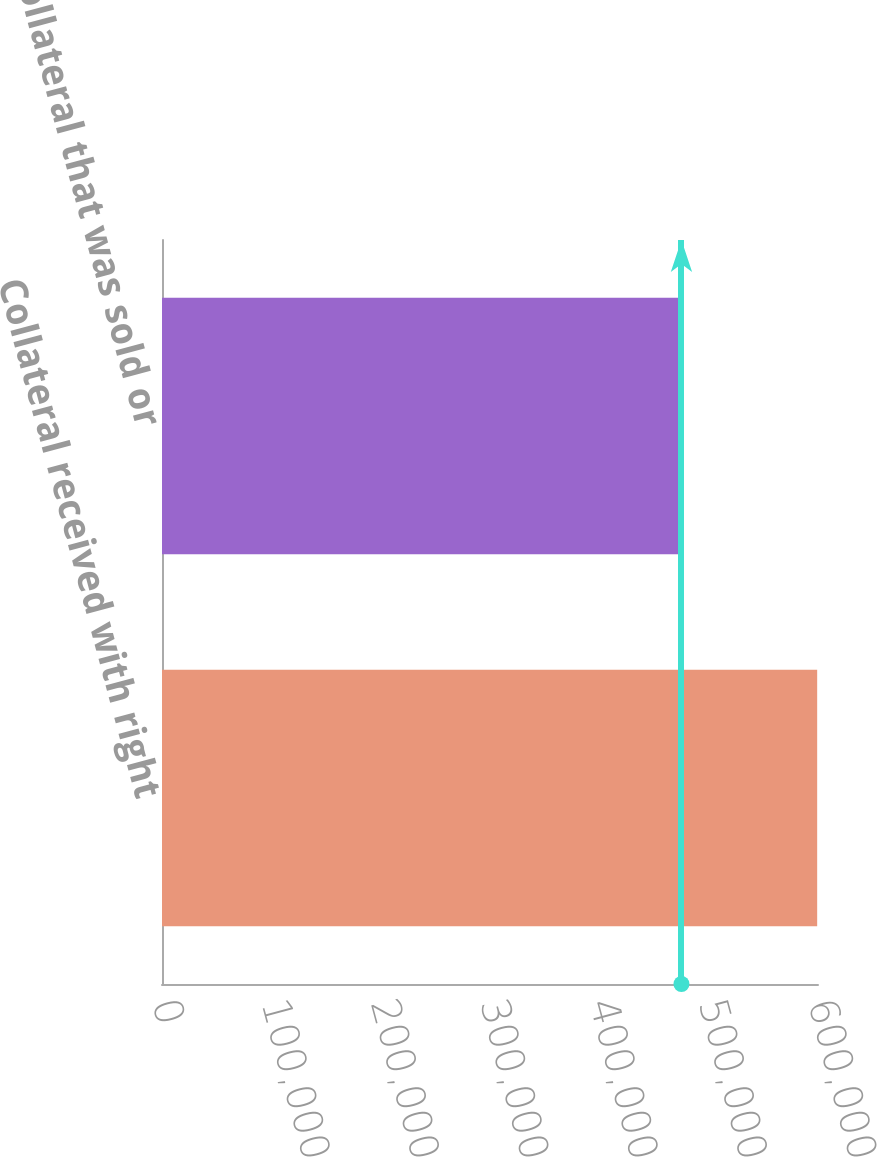Convert chart. <chart><loc_0><loc_0><loc_500><loc_500><bar_chart><fcel>Collateral received with right<fcel>Collateral that was sold or<nl><fcel>599244<fcel>475113<nl></chart> 